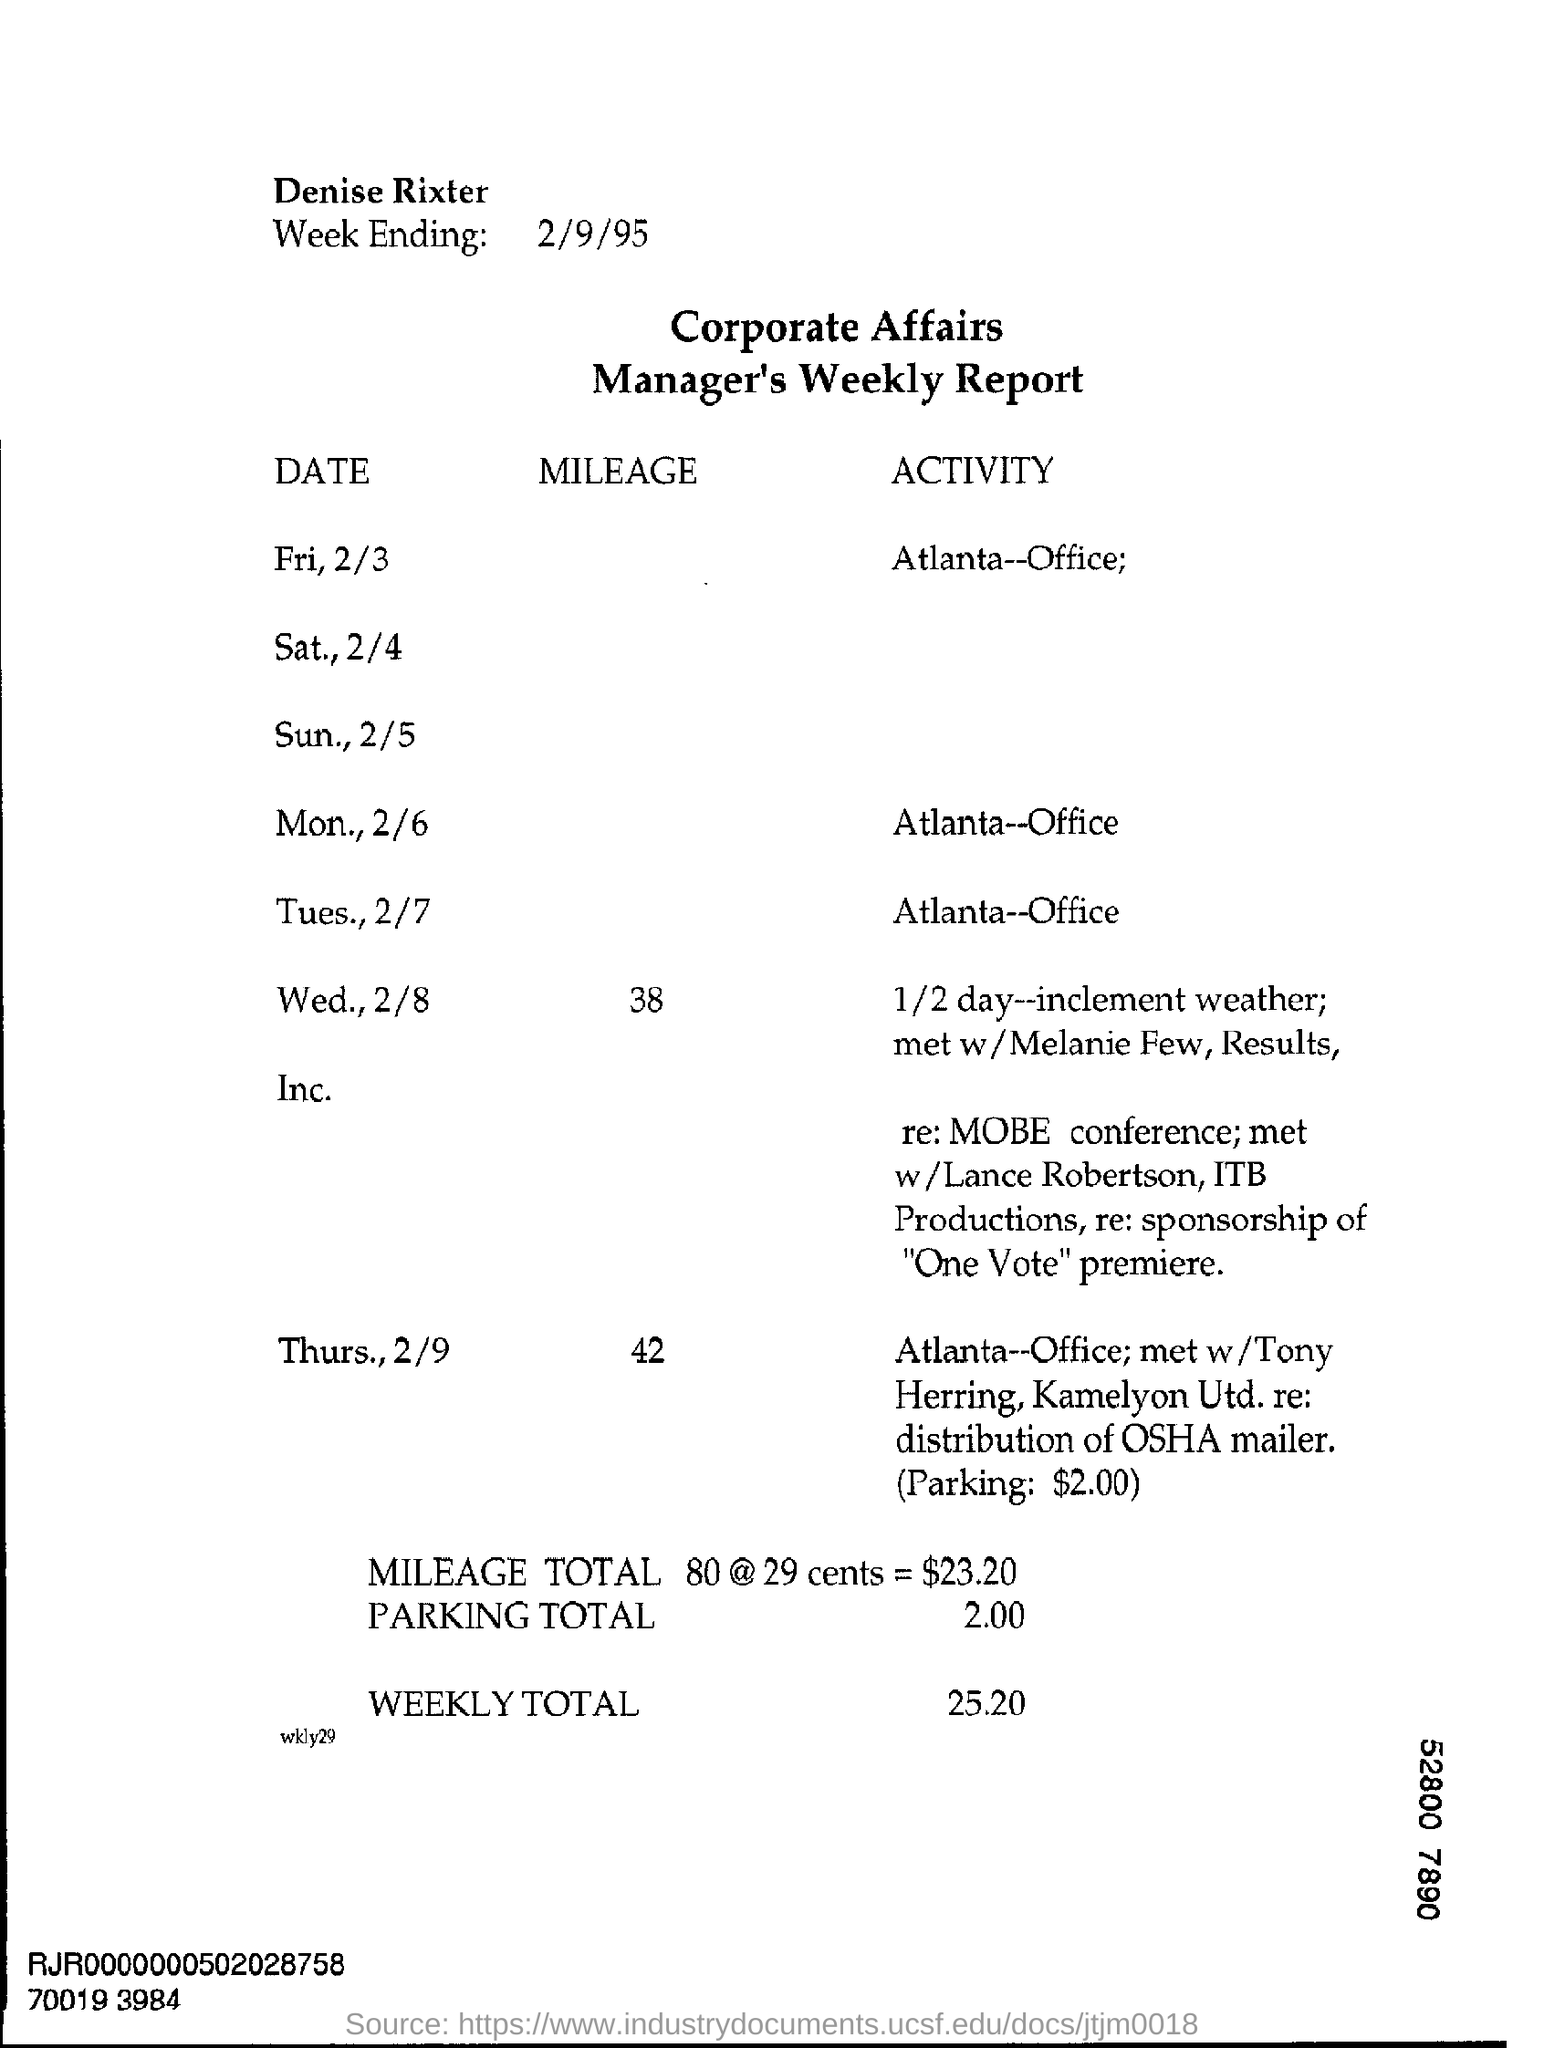What is date of week ending ?
Offer a terse response. 2/9/95. 